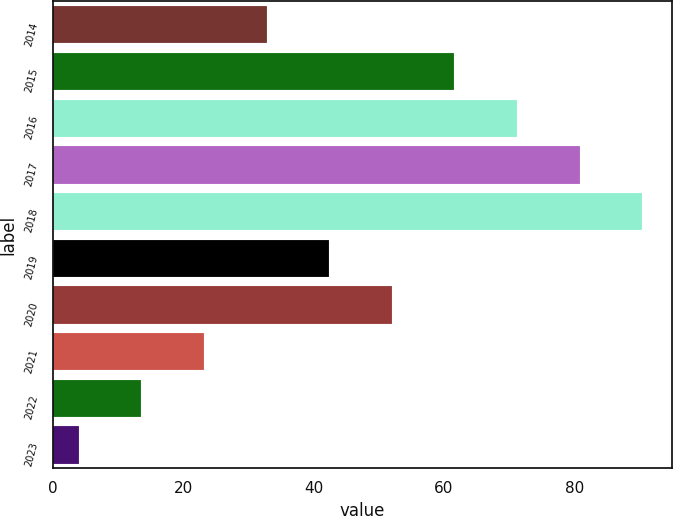Convert chart to OTSL. <chart><loc_0><loc_0><loc_500><loc_500><bar_chart><fcel>2014<fcel>2015<fcel>2016<fcel>2017<fcel>2018<fcel>2019<fcel>2020<fcel>2021<fcel>2022<fcel>2023<nl><fcel>32.8<fcel>61.6<fcel>71.2<fcel>80.8<fcel>90.4<fcel>42.4<fcel>52<fcel>23.2<fcel>13.6<fcel>4<nl></chart> 